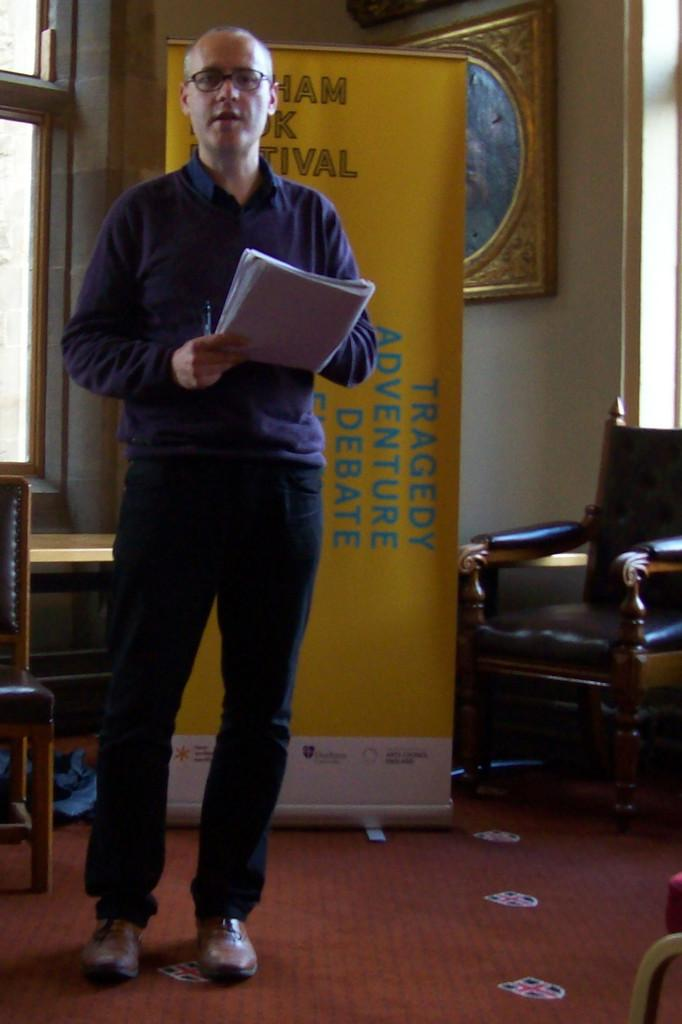Who is present in the image? There is a man in the image. What is the man holding in his hands? The man is holding a book and a pen. What else can be seen in the image besides the man? There is a banner and a chair in the image. Where is the playground located in the image? There is no playground present in the image. What type of wire is being used to hold the banner in the image? There is no wire visible in the image; the banner is not shown to be held up by any wire. 